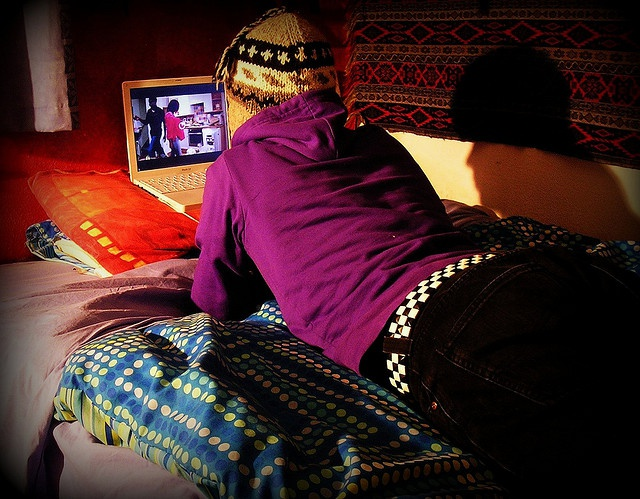Describe the objects in this image and their specific colors. I can see people in black, purple, and maroon tones, bed in black, maroon, red, and gray tones, laptop in black, orange, purple, and lavender tones, and people in black, navy, darkblue, and purple tones in this image. 